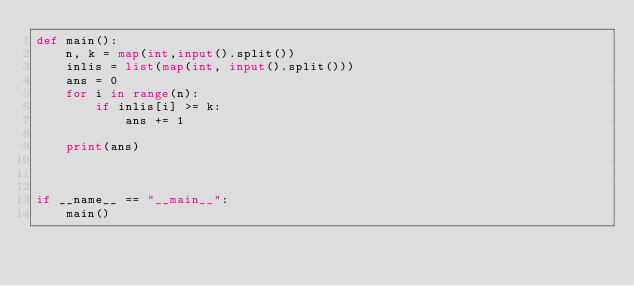<code> <loc_0><loc_0><loc_500><loc_500><_Python_>def main():
    n, k = map(int,input().split())
    inlis = list(map(int, input().split()))
    ans = 0
    for i in range(n):
        if inlis[i] >= k:
            ans += 1

    print(ans)
    
    
    
if __name__ == "__main__":
    main()
</code> 